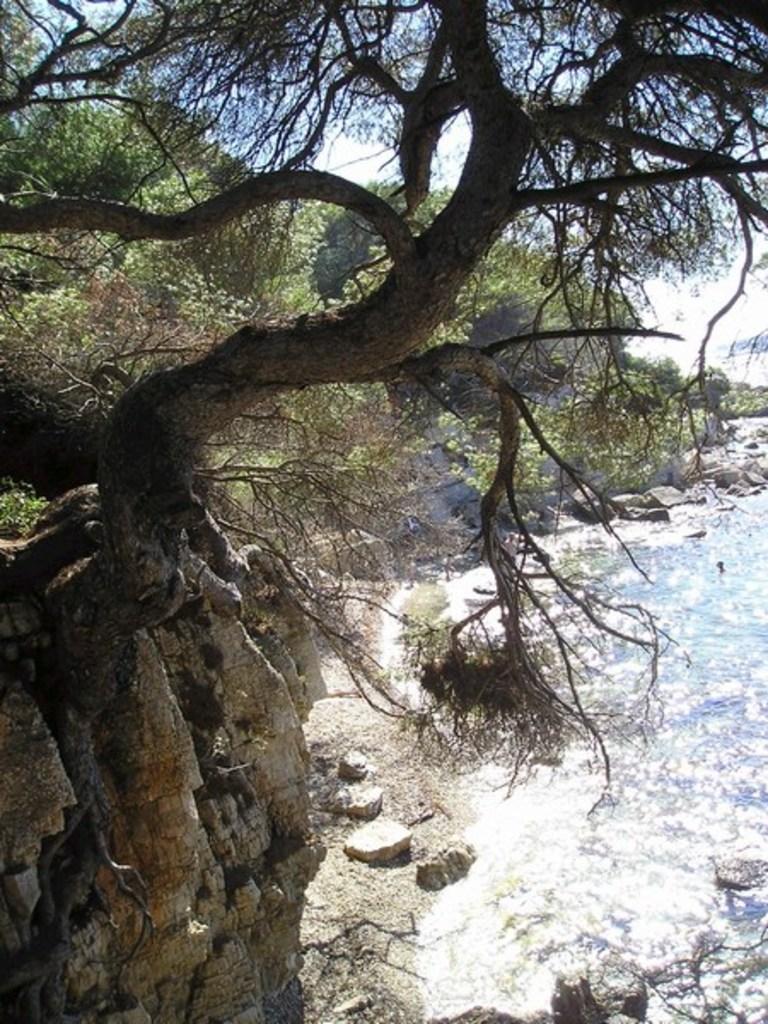Describe this image in one or two sentences. This picture is clicked outside. In the foreground we can see a water body and the trees. In the background we can see the sky, trees and rocks and some other objects. 